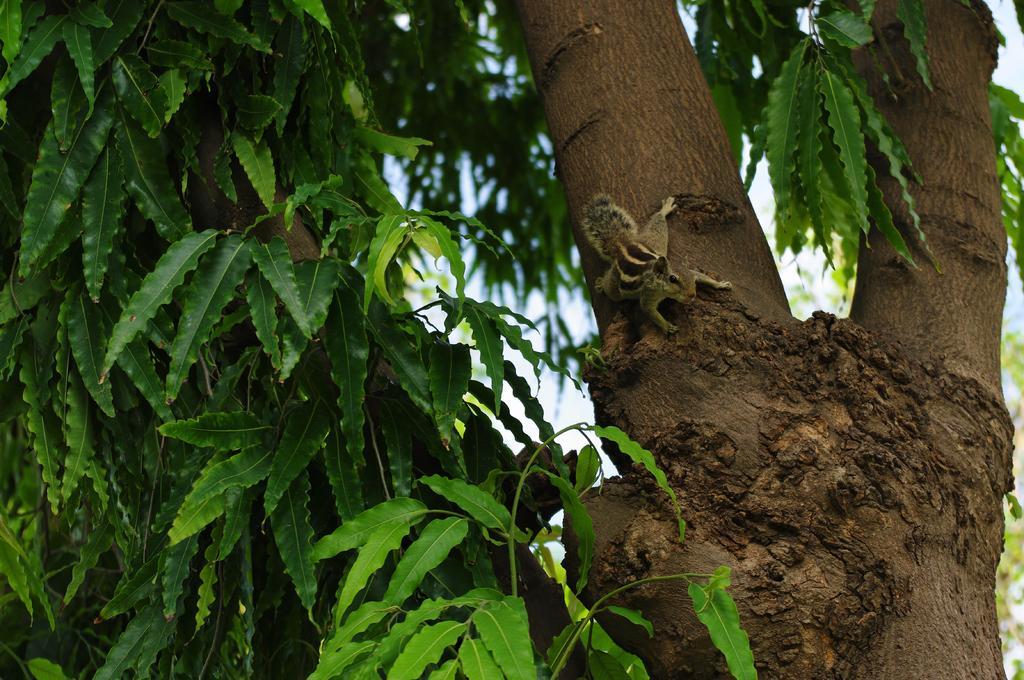How would you summarize this image in a sentence or two? In this image there is a squirrel on the branch of a tree. 